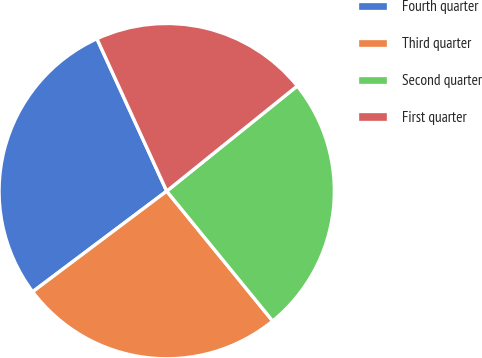Convert chart. <chart><loc_0><loc_0><loc_500><loc_500><pie_chart><fcel>Fourth quarter<fcel>Third quarter<fcel>Second quarter<fcel>First quarter<nl><fcel>28.41%<fcel>25.64%<fcel>24.9%<fcel>21.04%<nl></chart> 